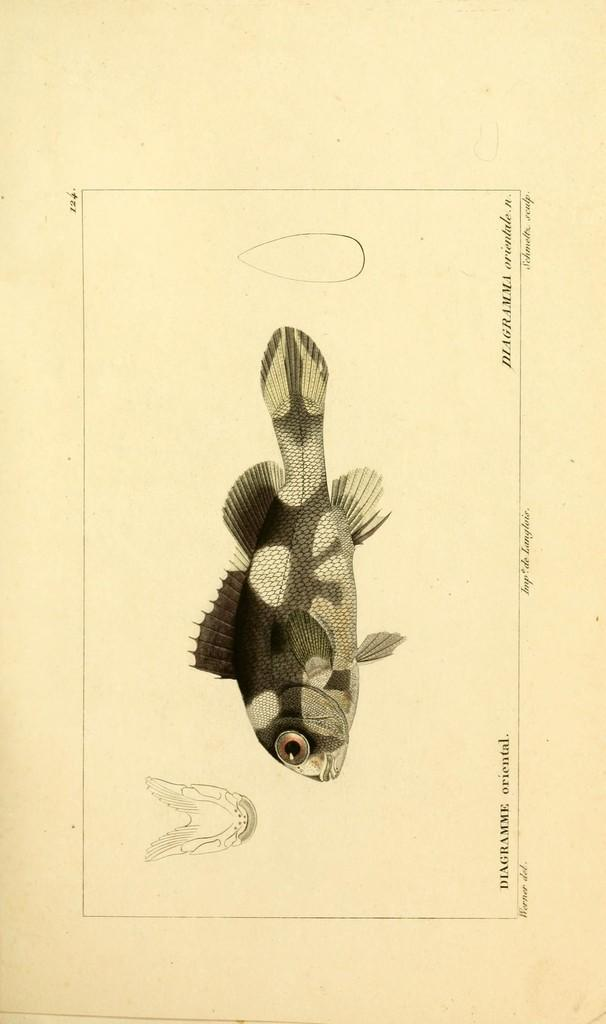What can be seen in the image that is not text? There are drawings in the image. What can be seen in the image that is text? There is writing on the image. How many waves can be seen in the image? There are no waves present in the image. What actor is depicted in the image? There is no actor depicted in the image. 